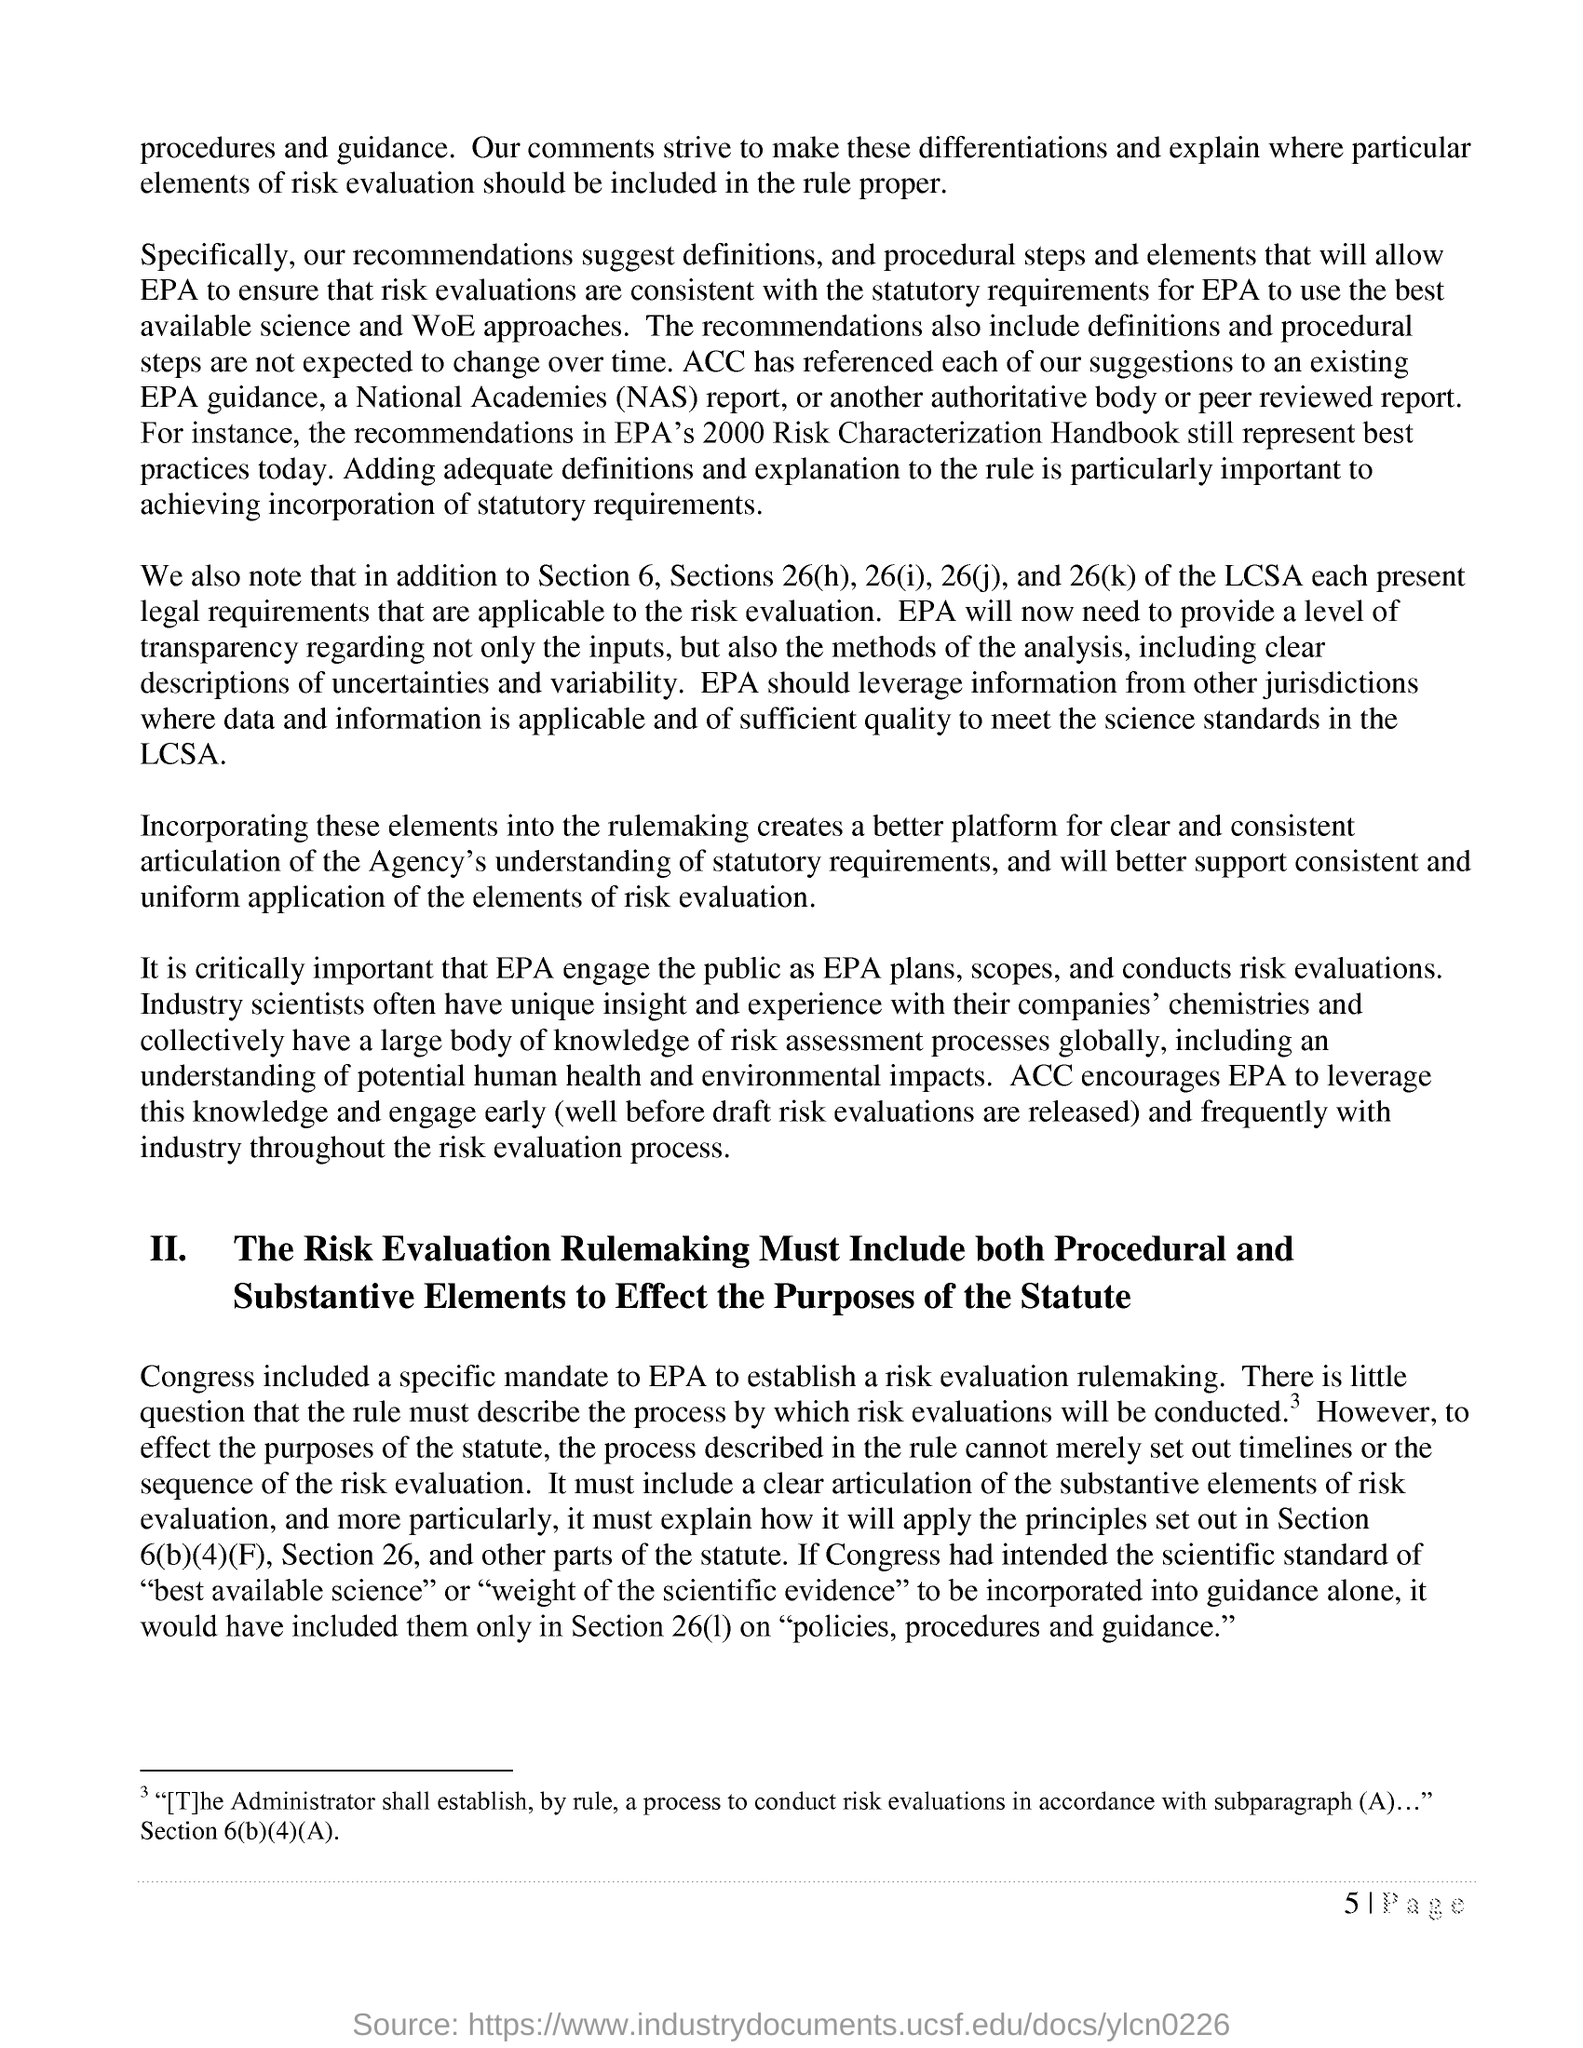Recommendations in which "Handbook" still represent best practices today?
Give a very brief answer. EPA's 2000 Risk Characterization Handbook. In addition to Section 6, which all Sections of the LCSA present legal requirements that are applicable to the risk evaluation?
Keep it short and to the point. Sections 26(h), 26(i), 26(j), and 26(k). What "encourages EPA to leverage this knowledge and engage early and frequently with industry throughout the risk evaluation process"?
Provide a succinct answer. ACC. What is the side heading mentioned as "II."?
Your response must be concise. The Risk Evaluation Rulemaking Must Include both Procedural and Substantive Elements to Effect the Purposes of the Statute. What all must "Risk Evaluation Rulemaking Include  to Effect the Purposes of the Statute"?
Make the answer very short. Both Procedural and Substantive Elements. "Congress included a specific mandate to" what to establish a risk evaluation rulemaking?
Your response must be concise. EPA. What is the fullform of NAS?
Your answer should be compact. National Academies. 